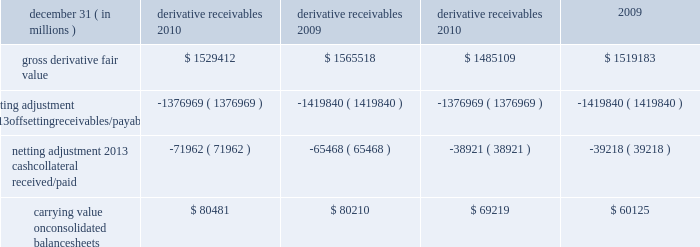Jpmorgan chase & co./2010 annual report 197 the table shows the current credit risk of derivative receivables after netting adjustments , and the current liquidity risk of derivative payables after netting adjustments , as of december 31 , 2010 and 2009. .
In addition to the collateral amounts reflected in the table above , at december 31 , 2010 and 2009 , the firm had received liquid securi- ties and other cash collateral in the amount of $ 16.5 billion and $ 15.5 billion , respectively , and had posted $ 10.9 billion and $ 11.7 billion , respectively .
The firm also receives and delivers collateral at the initiation of derivative transactions , which is available as secu- rity against potential exposure that could arise should the fair value of the transactions move in the firm 2019s or client 2019s favor , respectively .
Furthermore , the firm and its counterparties hold collateral related to contracts that have a non-daily call frequency for collateral to be posted , and collateral that the firm or a counterparty has agreed to return but has not yet settled as of the reporting date .
At december 31 , 2010 and 2009 , the firm had received $ 18.0 billion and $ 16.9 billion , respectively , and delivered $ 8.4 billion and $ 5.8 billion , respectively , of such additional collateral .
These amounts were not netted against the derivative receivables and payables in the table above , because , at an individual counterparty level , the collateral exceeded the fair value exposure at december 31 , 2010 and 2009 .
Credit derivatives credit derivatives are financial instruments whose value is derived from the credit risk associated with the debt of a third-party issuer ( the reference entity ) and which allow one party ( the protection purchaser ) to transfer that risk to another party ( the protection seller ) .
Credit derivatives expose the protection purchaser to the creditworthiness of the protection seller , as the protection seller is required to make payments under the contract when the reference entity experiences a credit event , such as a bankruptcy , a failure to pay its obligation or a restructuring .
The seller of credit protection receives a premium for providing protection but has the risk that the underlying instrument referenced in the contract will be subject to a credit event .
The firm is both a purchaser and seller of protection in the credit derivatives market and uses these derivatives for two primary purposes .
First , in its capacity as a market-maker in the dealer/client business , the firm actively risk manages a portfolio of credit derivatives by purchasing and selling credit protection , pre- dominantly on corporate debt obligations , to meet the needs of customers .
As a seller of protection , the firm 2019s exposure to a given reference entity may be offset partially , or entirely , with a contract to purchase protection from another counterparty on the same or similar reference entity .
Second , the firm uses credit derivatives to mitigate credit risk associated with its overall derivative receivables and traditional commercial credit lending exposures ( loans and unfunded commitments ) as well as to manage its exposure to residential and commercial mortgages .
See note 3 on pages 170 2013 187 of this annual report for further information on the firm 2019s mortgage-related exposures .
In accomplishing the above , the firm uses different types of credit derivatives .
Following is a summary of various types of credit derivatives .
Credit default swaps credit derivatives may reference the credit of either a single refer- ence entity ( 201csingle-name 201d ) or a broad-based index .
The firm purchases and sells protection on both single- name and index- reference obligations .
Single-name cds and index cds contracts are otc derivative contracts .
Single-name cds are used to manage the default risk of a single reference entity , while index cds con- tracts are used to manage the credit risk associated with the broader credit markets or credit market segments .
Like the s&p 500 and other market indices , a cds index comprises a portfolio of cds across many reference entities .
New series of cds indices are periodically established with a new underlying portfolio of reference entities to reflect changes in the credit markets .
If one of the refer- ence entities in the index experiences a credit event , then the reference entity that defaulted is removed from the index .
Cds can also be referenced against specific portfolios of reference names or against customized exposure levels based on specific client de- mands : for example , to provide protection against the first $ 1 million of realized credit losses in a $ 10 million portfolio of expo- sure .
Such structures are commonly known as tranche cds .
For both single-name cds contracts and index cds contracts , upon the occurrence of a credit event , under the terms of a cds contract neither party to the cds contract has recourse to the reference entity .
The protection purchaser has recourse to the protection seller for the difference between the face value of the cds contract and the fair value of the reference obligation at the time of settling the credit derivative contract , also known as the recovery value .
The protection purchaser does not need to hold the debt instrument of the underlying reference entity in order to receive amounts due under the cds contract when a credit event occurs .
Credit-related notes a credit-related note is a funded credit derivative where the issuer of the credit-related note purchases from the note investor credit protec- tion on a referenced entity .
Under the contract , the investor pays the issuer the par value of the note at the inception of the transaction , and in return , the issuer pays periodic payments to the investor , based on the credit risk of the referenced entity .
The issuer also repays the investor the par value of the note at maturity unless the reference entity experiences a specified credit event .
If a credit event .
What was the maximum amount of credit risk booked in the last four years , in billions? 
Computations: table_max(carrying value onconsolidated balancesheets, none)
Answer: 80481.0. 